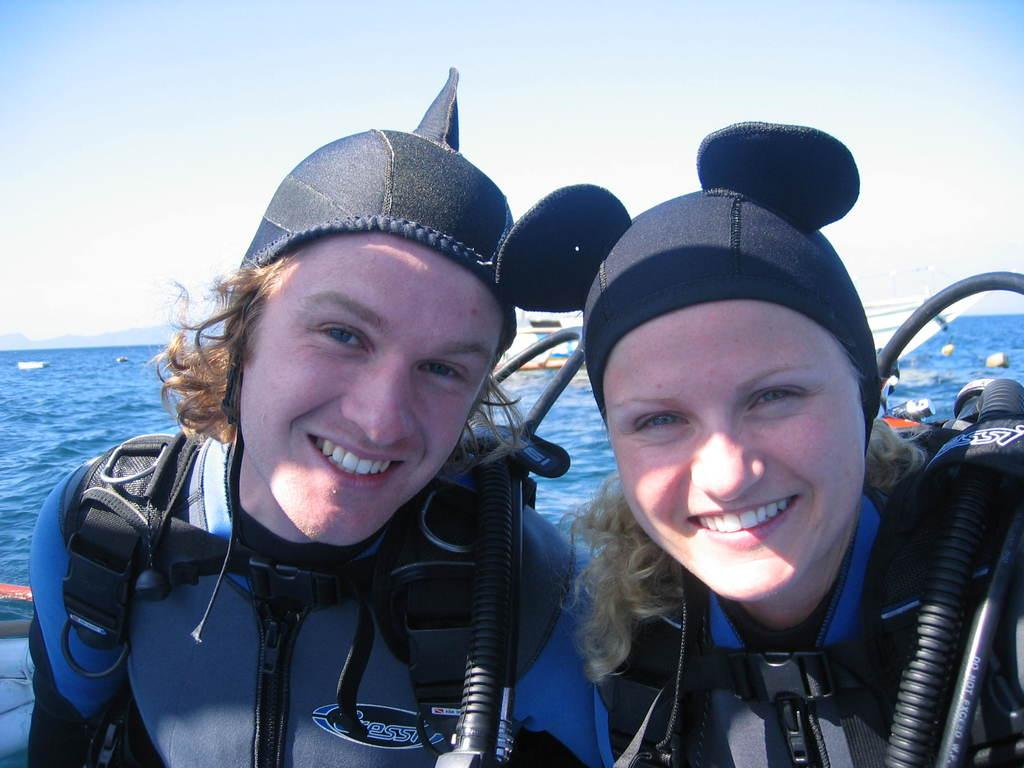Who is present in the image? There is a man and a woman in the image. What expressions do the man and woman have in the image? Both the man and the woman are smiling in the image. What can be seen in the background of the image? There are hills, sky, and water visible in the background of the image. What type of music can be heard coming from the hills in the image? There is no music present in the image, as it only features a man, a woman, and the background scenery. 